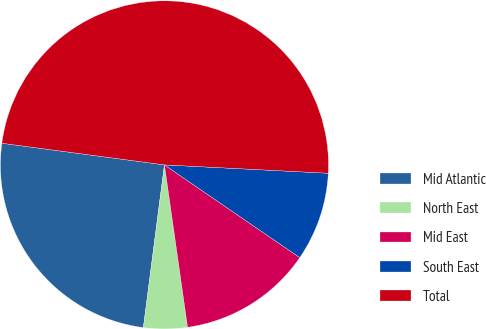Convert chart. <chart><loc_0><loc_0><loc_500><loc_500><pie_chart><fcel>Mid Atlantic<fcel>North East<fcel>Mid East<fcel>South East<fcel>Total<nl><fcel>25.06%<fcel>4.3%<fcel>13.19%<fcel>8.75%<fcel>48.71%<nl></chart> 